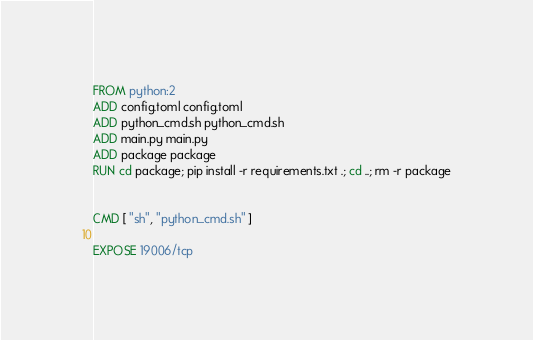<code> <loc_0><loc_0><loc_500><loc_500><_Dockerfile_>FROM python:2
ADD config.toml config.toml
ADD python_cmd.sh python_cmd.sh
ADD main.py main.py
ADD package package
RUN cd package; pip install -r requirements.txt .; cd ..; rm -r package


CMD [ "sh", "python_cmd.sh" ]

EXPOSE 19006/tcp
</code> 